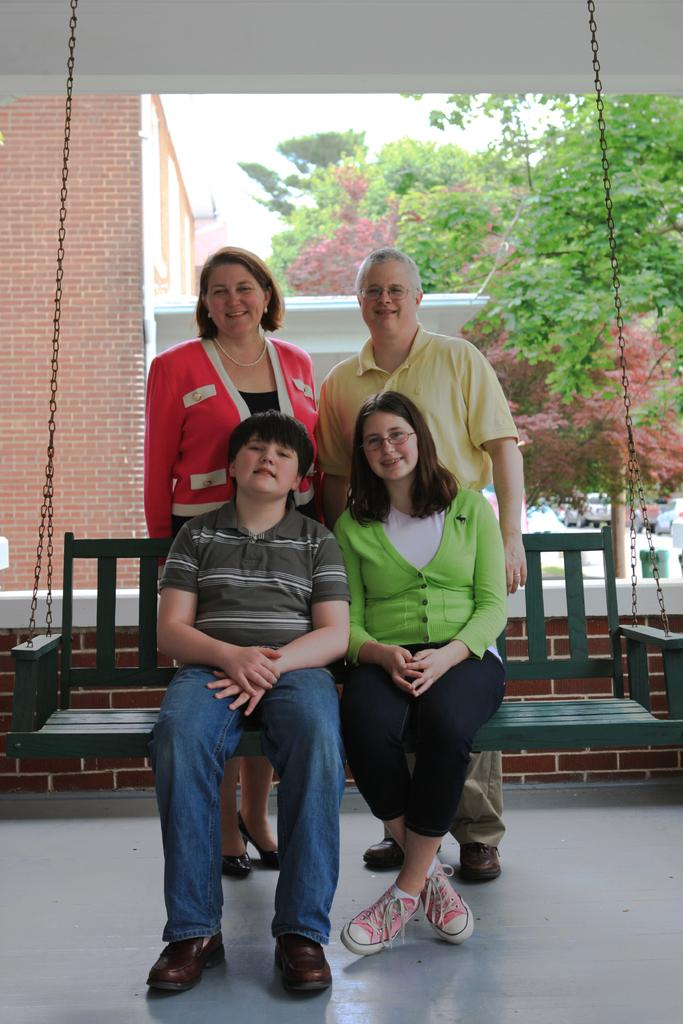How many persons are sitting in the image? There are two persons sitting on a cradle in the image. How many persons are standing in the image? There are two persons standing on the floor in the image. What can be seen in the background of the image? There are trees, a wall, and the sky visible in the background of the image. What type of clock is hanging on the wall in the image? There is no clock visible in the image; only trees, a wall, and the sky are present in the background. 